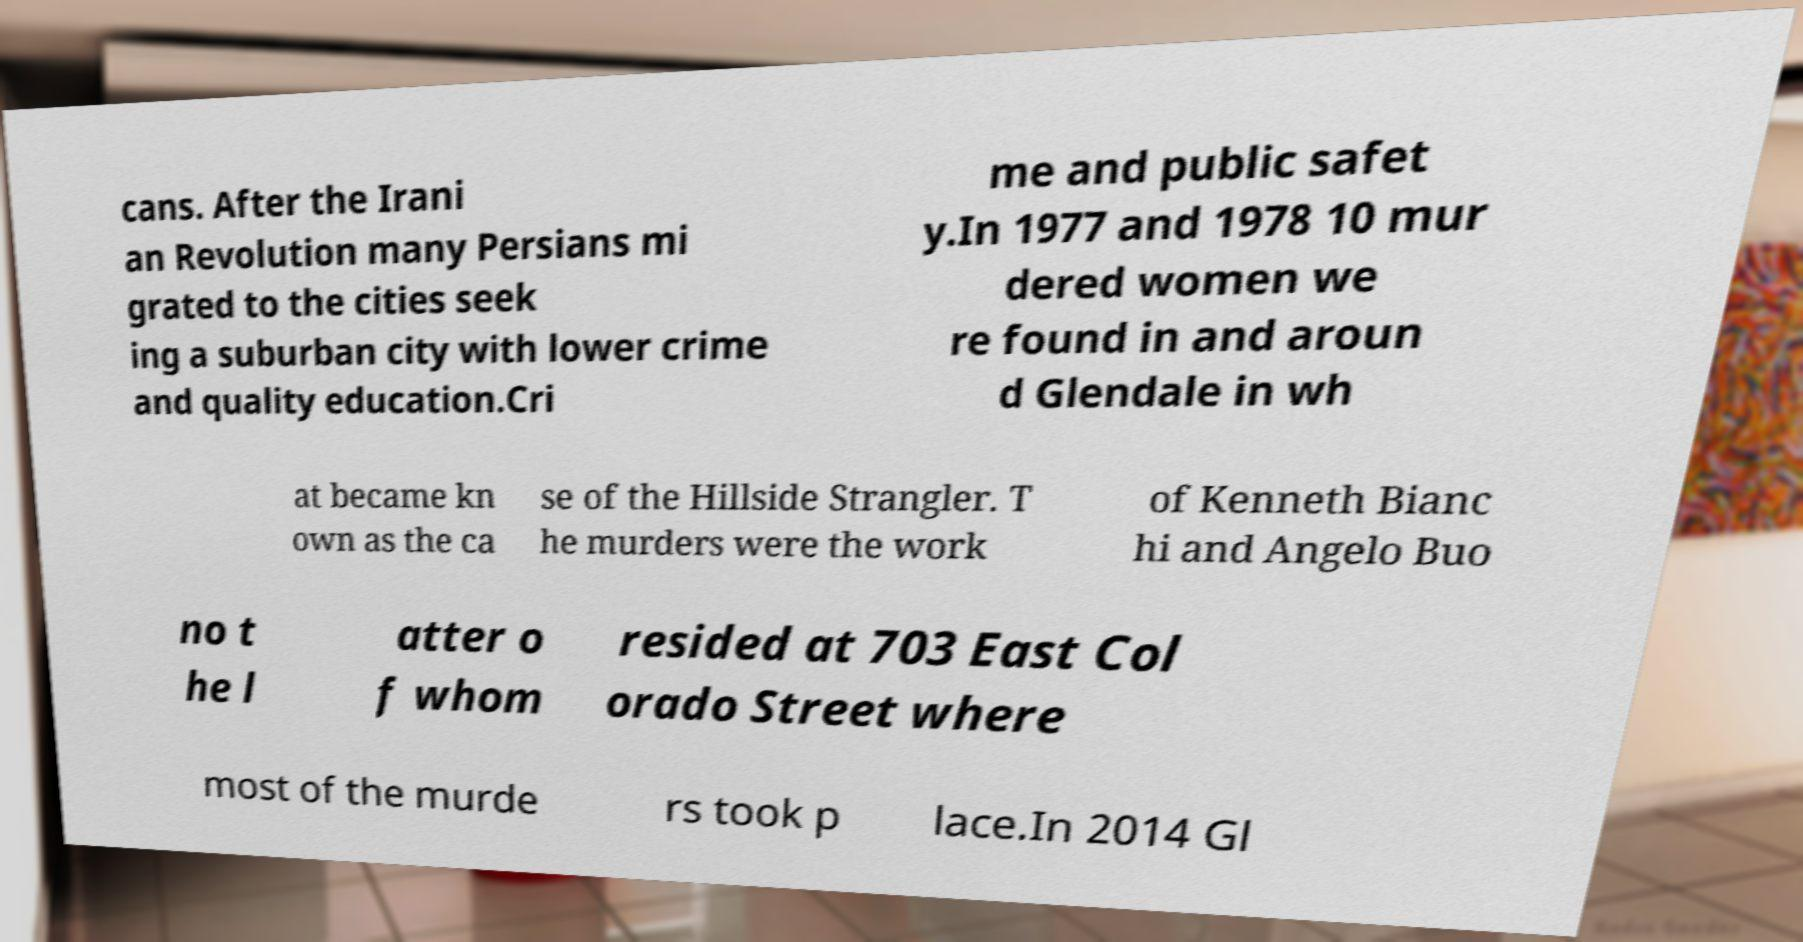Could you assist in decoding the text presented in this image and type it out clearly? cans. After the Irani an Revolution many Persians mi grated to the cities seek ing a suburban city with lower crime and quality education.Cri me and public safet y.In 1977 and 1978 10 mur dered women we re found in and aroun d Glendale in wh at became kn own as the ca se of the Hillside Strangler. T he murders were the work of Kenneth Bianc hi and Angelo Buo no t he l atter o f whom resided at 703 East Col orado Street where most of the murde rs took p lace.In 2014 Gl 